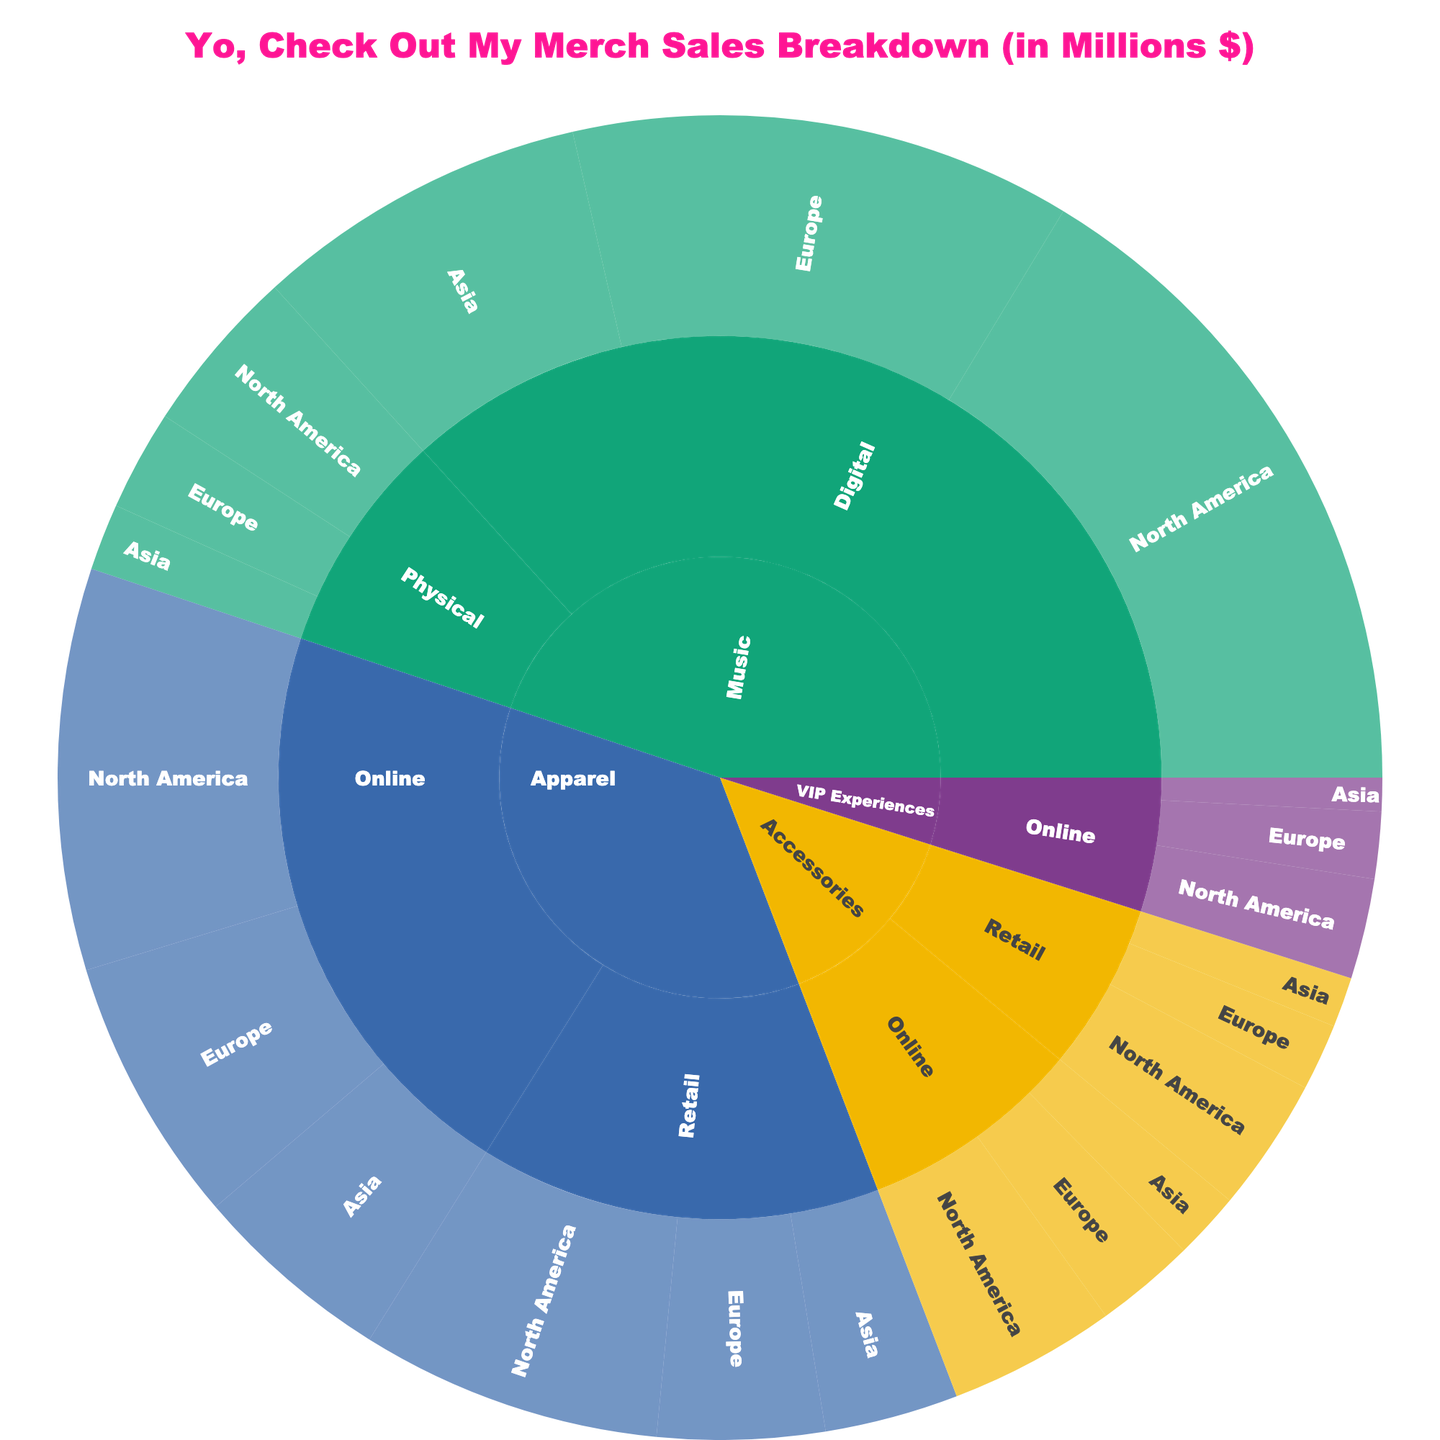what is the category with the highest total sales? Looking at the outer ring of the sunburst, the largest segment corresponds to the "Music" category. On the plot, we can see that Music has higher sales in both the "Digital" and "Physical" channels.
Answer: Music How much are the total sales for VIP Experiences? By summing up the sales for VIP Experiences in all regions: $300K in North America, $200K in Europe, and $100K in Asia, the total becomes $600K.
Answer: $0.6M Which region dominates the sales of Accessories in the Retail channel? On the sunburst plot, find the Retail segment under Accessories and look at the sub-regions. North America has the highest value compared to Europe and Asia within Accessories-Retail.
Answer: North America Compare the sales of Apparel in Online channels vs Retail channels. Sum up all the regions for each channel: Online (NA+Europe+Asia: $1.2M + $0.8M + $0.6M = $2.6M) vs Retail (NA+Europe+Asia: $0.9M + $0.5M + $0.4M = $1.8M). Hence, Online sales are higher.
Answer: Online is greater What is the smallest sales segment within Music? Locate the sub-categories under Music, then check Digital and Physical channels. Among these, Physical sales in Asia is the smallest segment.
Answer: Physical in Asia What is the total sales amount across all categories in Europe? Sum the sales for all categories in Europe: Apparel ($0.8M + $0.5M), Accessories ($0.3M + $0.2M), Music ($1.5M + $0.3M), VIP ($0.2M). This gives $3.8M.
Answer: $3.8M Which distribution channel has the lowest total sales for North America? Compare the sum of all channels in North America: Digital (Music $2M), Online (Apparel $1.2M + Accessories $0.5M), Retail (Apparel $0.9M + Accessories $0.4M + Physical $0.5M = $1.8M). The channel with the lowest sales is Retail.
Answer: Retail Which category-channel combination has the highest sales in Asia? In Asia, check all sub-categories and channels. The highest sales are under Music in the Digital channel.
Answer: Music-Digital What is the difference in sales between Apparel in North America and Europe’s Retail channels? For North America Apparel-Retail: $0.9M, for Europe Apparel-Retail: $0.5M. The difference is $0.9M - $0.5M = $0.4M.
Answer: $0.4M How do the total Online sales compare between Accessories and VIP Experiences? Sum Online sales for both categories: Accessories ($0.5M + $0.3M + $0.2M = $1M), VIP ($0.3M + $0.2M + $0.1M = $0.6M). Accessories Online sales are greater.
Answer: Accessories is higher 